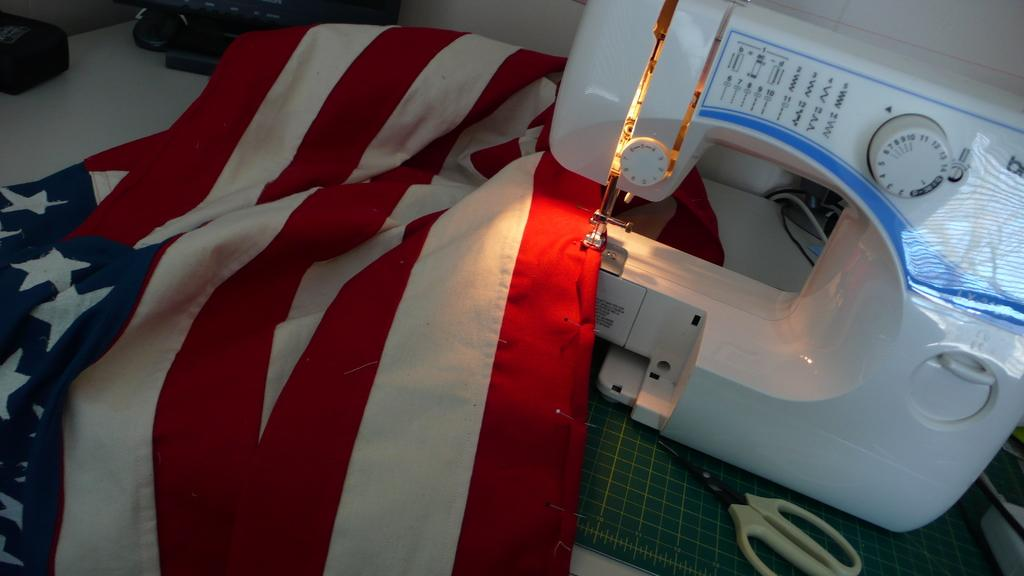What type of furniture is present in the image? There is a table in the image. What is the decorative or symbolic item in the image? There is a flag in the image. What type of equipment is used for sewing in the image? There is a sewing machine in the image. What tool is used for cutting in the image? There are scissors in the image. How would you describe the lighting in the image? The image is slightly dark. What type of musical instrument is being played in the image? There is no musical instrument being played in the image. What type of pot is used for cooking in the image? There is no pot present in the image. 